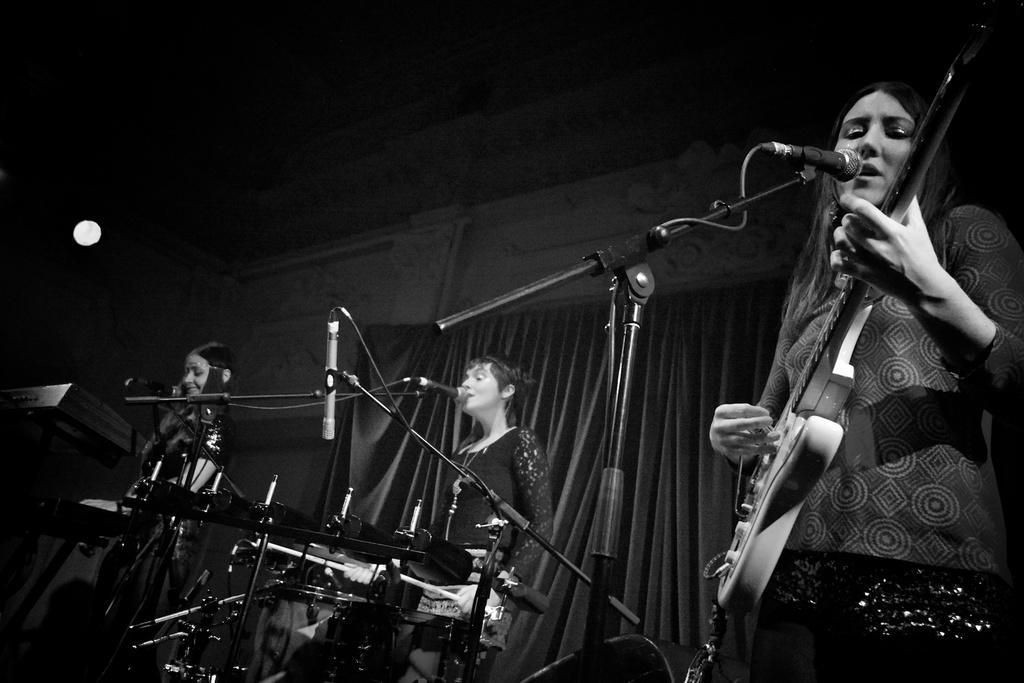Can you describe this image briefly? In this image i can see a there are three women are playing musical instruments in front of a microphone. 